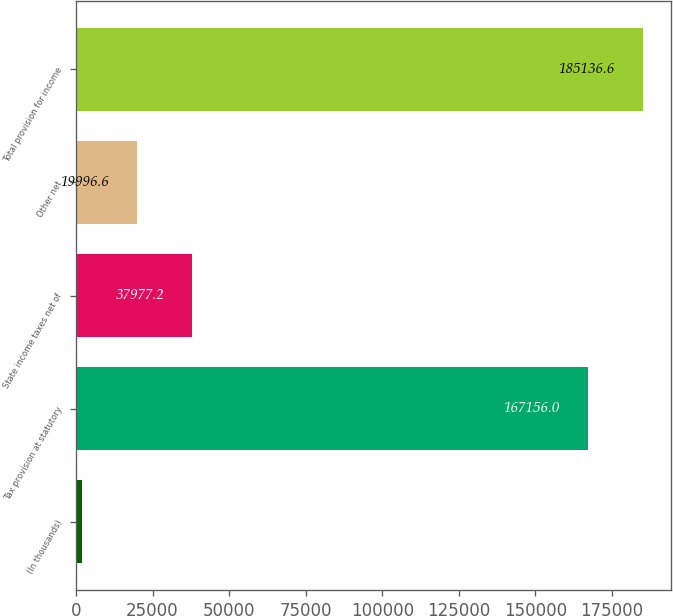Convert chart to OTSL. <chart><loc_0><loc_0><loc_500><loc_500><bar_chart><fcel>(In thousands)<fcel>Tax provision at statutory<fcel>State income taxes net of<fcel>Other net<fcel>Total provision for income<nl><fcel>2016<fcel>167156<fcel>37977.2<fcel>19996.6<fcel>185137<nl></chart> 